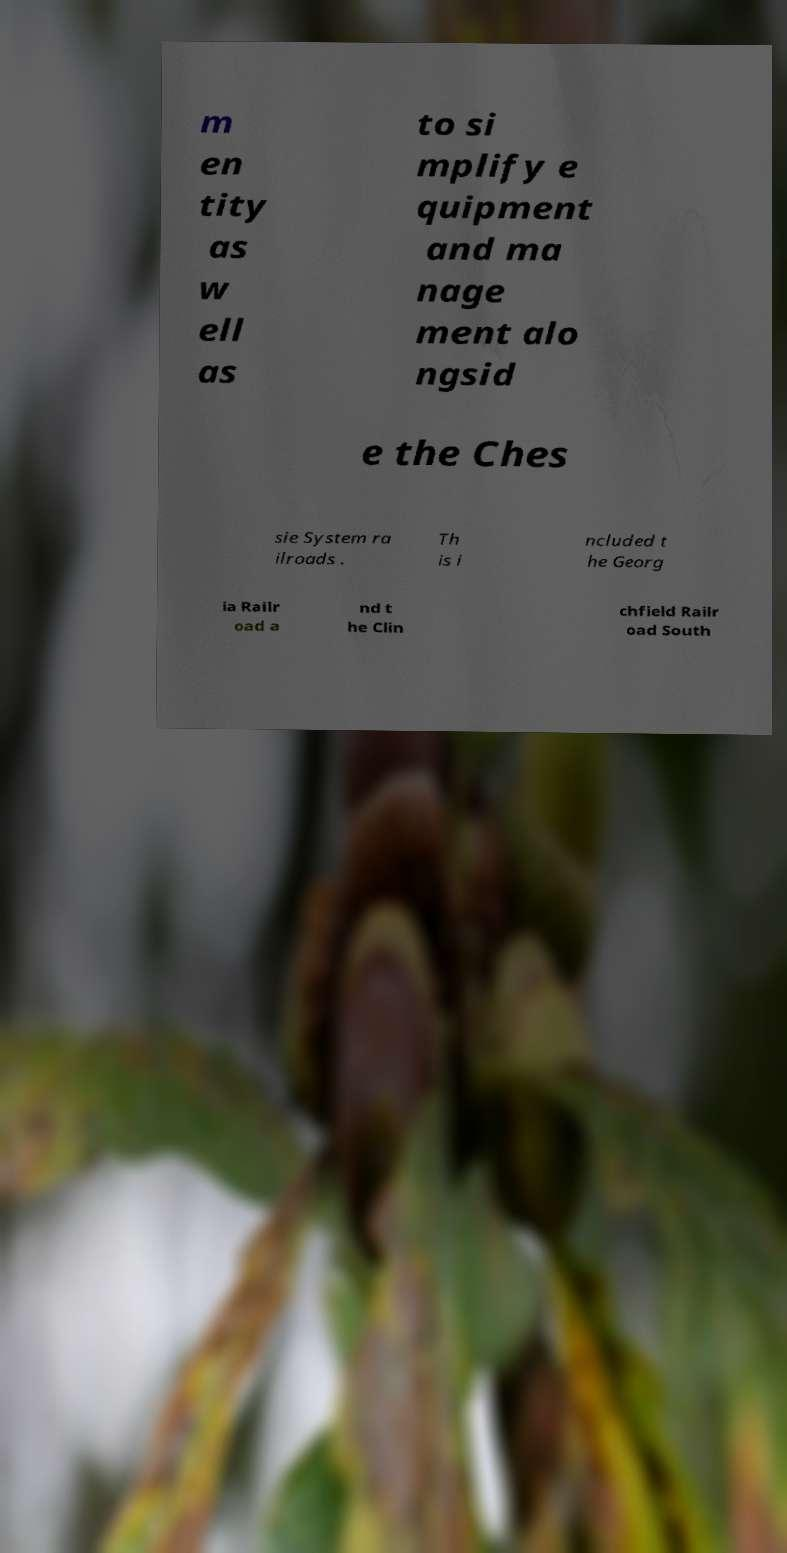Could you extract and type out the text from this image? m en tity as w ell as to si mplify e quipment and ma nage ment alo ngsid e the Ches sie System ra ilroads . Th is i ncluded t he Georg ia Railr oad a nd t he Clin chfield Railr oad South 